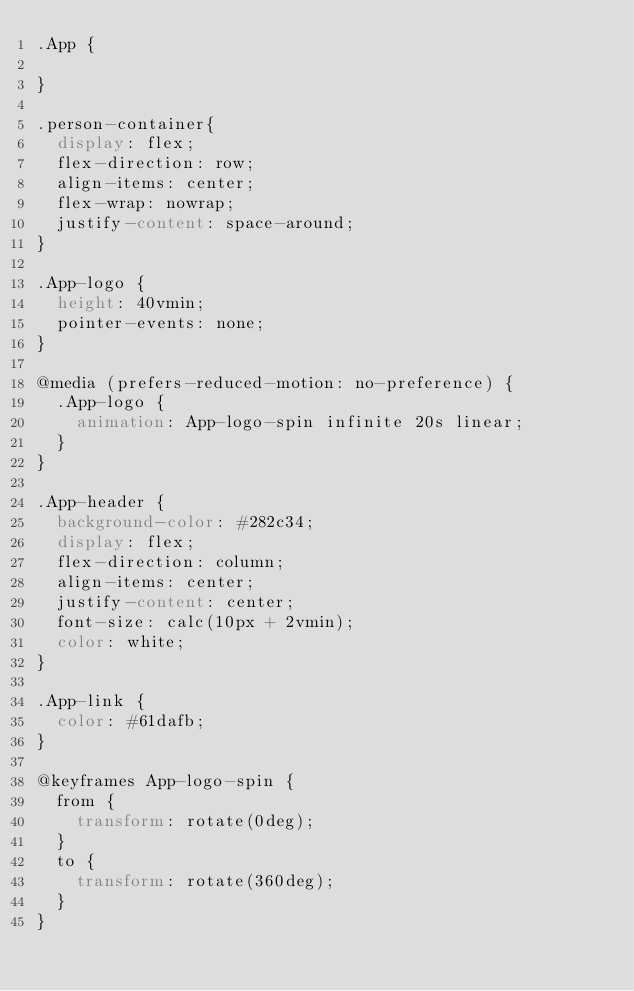Convert code to text. <code><loc_0><loc_0><loc_500><loc_500><_CSS_>.App {

}

.person-container{
  display: flex;
  flex-direction: row;
  align-items: center;
  flex-wrap: nowrap;
  justify-content: space-around;
}

.App-logo {
  height: 40vmin;
  pointer-events: none;
}

@media (prefers-reduced-motion: no-preference) {
  .App-logo {
    animation: App-logo-spin infinite 20s linear;
  }
}

.App-header {
  background-color: #282c34;
  display: flex;
  flex-direction: column;
  align-items: center;
  justify-content: center;
  font-size: calc(10px + 2vmin);
  color: white;
}

.App-link {
  color: #61dafb;
}

@keyframes App-logo-spin {
  from {
    transform: rotate(0deg);
  }
  to {
    transform: rotate(360deg);
  }
}
</code> 